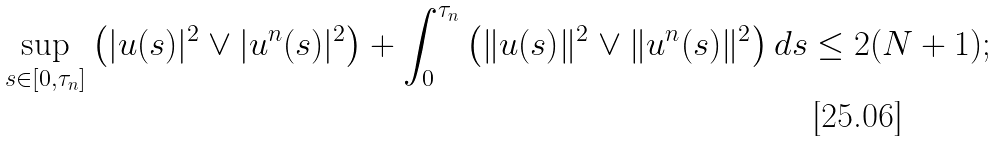<formula> <loc_0><loc_0><loc_500><loc_500>\sup _ { s \in [ 0 , \tau _ { n } ] } \left ( | u ( s ) | ^ { 2 } \vee | u ^ { n } ( s ) | ^ { 2 } \right ) + \int _ { 0 } ^ { \tau _ { n } } \left ( \| u ( s ) \| ^ { 2 } \vee \| u ^ { n } ( s ) \| ^ { 2 } \right ) d s \leq 2 ( N + 1 ) ;</formula> 